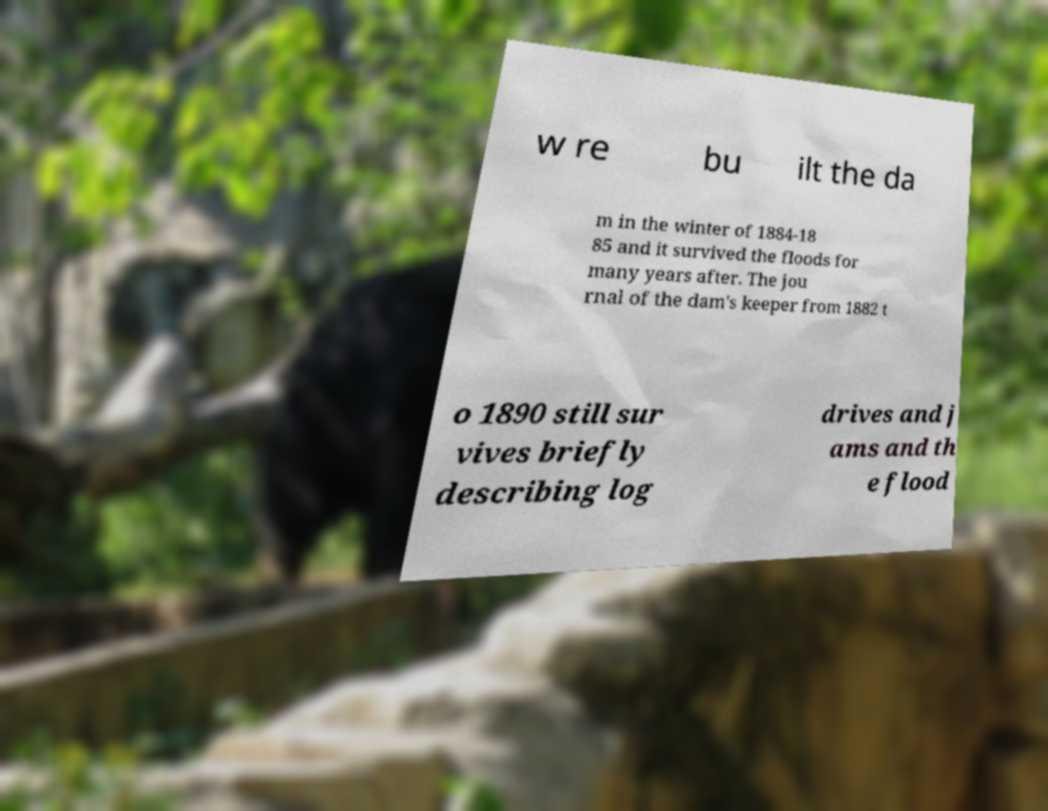What messages or text are displayed in this image? I need them in a readable, typed format. w re bu ilt the da m in the winter of 1884-18 85 and it survived the floods for many years after. The jou rnal of the dam's keeper from 1882 t o 1890 still sur vives briefly describing log drives and j ams and th e flood 